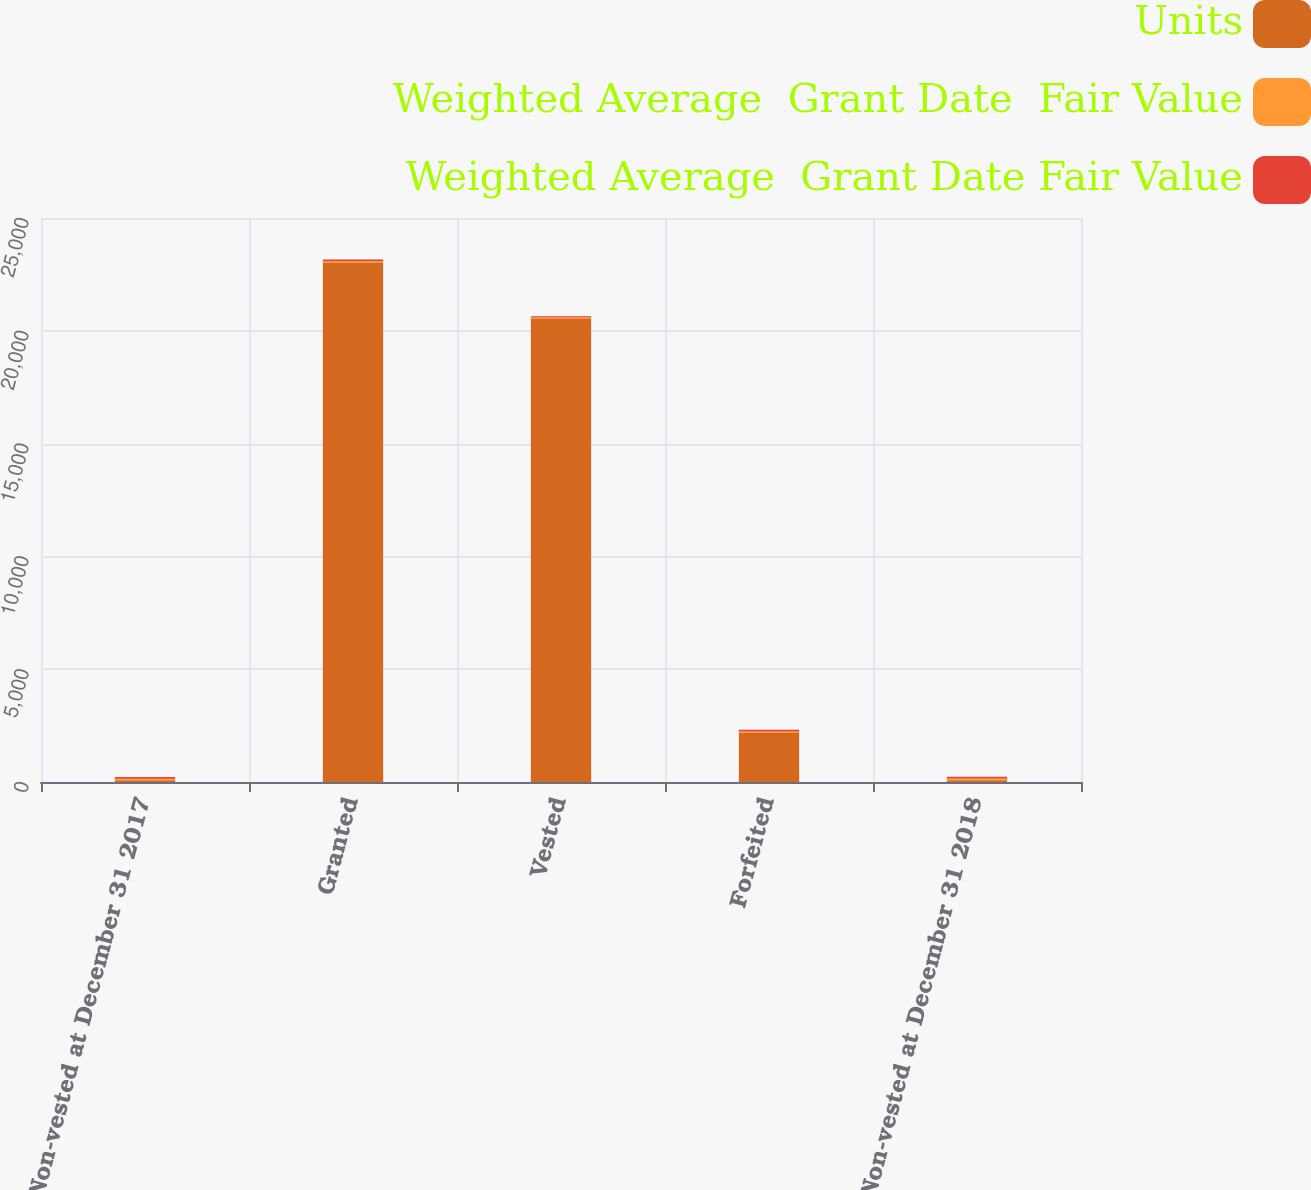<chart> <loc_0><loc_0><loc_500><loc_500><stacked_bar_chart><ecel><fcel>Non-vested at December 31 2017<fcel>Granted<fcel>Vested<fcel>Forfeited<fcel>Non-vested at December 31 2018<nl><fcel>Units<fcel>77.42<fcel>23000<fcel>20523<fcel>2167<fcel>77.42<nl><fcel>Weighted Average  Grant Date  Fair Value<fcel>71.93<fcel>77.94<fcel>61.03<fcel>73.93<fcel>77.42<nl><fcel>Weighted Average  Grant Date Fair Value<fcel>71.93<fcel>77.94<fcel>61.03<fcel>73.97<fcel>77.42<nl></chart> 